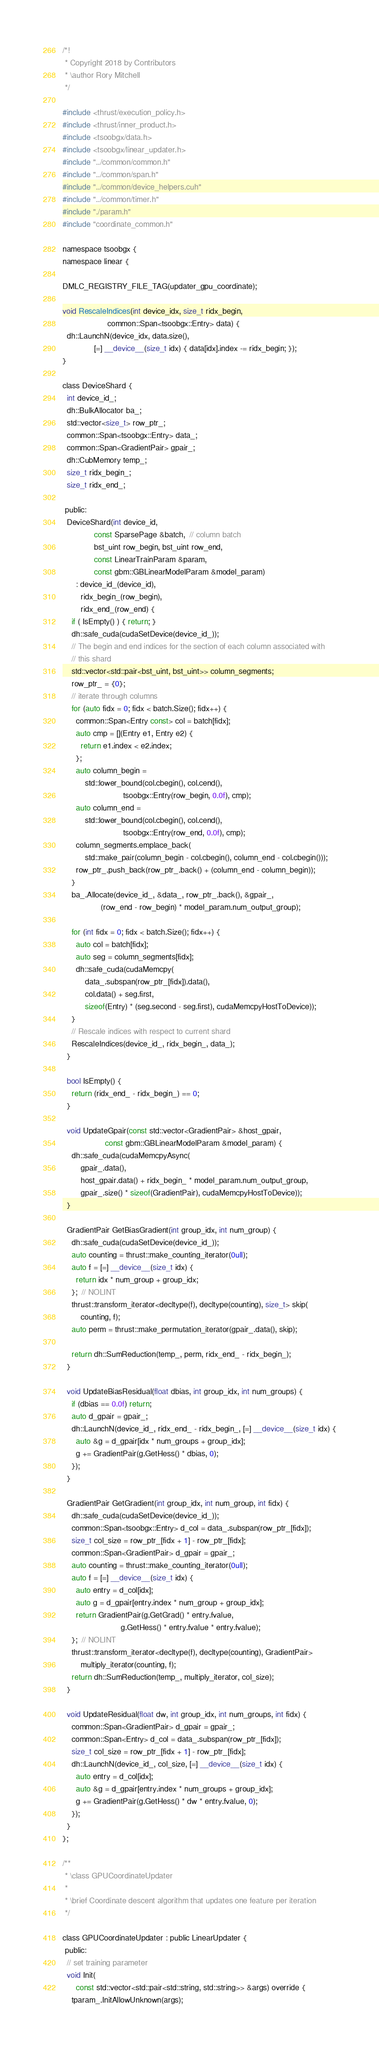<code> <loc_0><loc_0><loc_500><loc_500><_Cuda_>/*!
 * Copyright 2018 by Contributors
 * \author Rory Mitchell
 */

#include <thrust/execution_policy.h>
#include <thrust/inner_product.h>
#include <tsoobgx/data.h>
#include <tsoobgx/linear_updater.h>
#include "../common/common.h"
#include "../common/span.h"
#include "../common/device_helpers.cuh"
#include "../common/timer.h"
#include "./param.h"
#include "coordinate_common.h"

namespace tsoobgx {
namespace linear {

DMLC_REGISTRY_FILE_TAG(updater_gpu_coordinate);

void RescaleIndices(int device_idx, size_t ridx_begin,
                    common::Span<tsoobgx::Entry> data) {
  dh::LaunchN(device_idx, data.size(),
              [=] __device__(size_t idx) { data[idx].index -= ridx_begin; });
}

class DeviceShard {
  int device_id_;
  dh::BulkAllocator ba_;
  std::vector<size_t> row_ptr_;
  common::Span<tsoobgx::Entry> data_;
  common::Span<GradientPair> gpair_;
  dh::CubMemory temp_;
  size_t ridx_begin_;
  size_t ridx_end_;

 public:
  DeviceShard(int device_id,
              const SparsePage &batch,  // column batch
              bst_uint row_begin, bst_uint row_end,
              const LinearTrainParam &param,
              const gbm::GBLinearModelParam &model_param)
      : device_id_(device_id),
        ridx_begin_(row_begin),
        ridx_end_(row_end) {
    if ( IsEmpty() ) { return; }
    dh::safe_cuda(cudaSetDevice(device_id_));
    // The begin and end indices for the section of each column associated with
    // this shard
    std::vector<std::pair<bst_uint, bst_uint>> column_segments;
    row_ptr_ = {0};
    // iterate through columns
    for (auto fidx = 0; fidx < batch.Size(); fidx++) {
      common::Span<Entry const> col = batch[fidx];
      auto cmp = [](Entry e1, Entry e2) {
        return e1.index < e2.index;
      };
      auto column_begin =
          std::lower_bound(col.cbegin(), col.cend(),
                           tsoobgx::Entry(row_begin, 0.0f), cmp);
      auto column_end =
          std::lower_bound(col.cbegin(), col.cend(),
                           tsoobgx::Entry(row_end, 0.0f), cmp);
      column_segments.emplace_back(
          std::make_pair(column_begin - col.cbegin(), column_end - col.cbegin()));
      row_ptr_.push_back(row_ptr_.back() + (column_end - column_begin));
    }
    ba_.Allocate(device_id_, &data_, row_ptr_.back(), &gpair_,
                 (row_end - row_begin) * model_param.num_output_group);

    for (int fidx = 0; fidx < batch.Size(); fidx++) {
      auto col = batch[fidx];
      auto seg = column_segments[fidx];
      dh::safe_cuda(cudaMemcpy(
          data_.subspan(row_ptr_[fidx]).data(),
          col.data() + seg.first,
          sizeof(Entry) * (seg.second - seg.first), cudaMemcpyHostToDevice));
    }
    // Rescale indices with respect to current shard
    RescaleIndices(device_id_, ridx_begin_, data_);
  }

  bool IsEmpty() {
    return (ridx_end_ - ridx_begin_) == 0;
  }

  void UpdateGpair(const std::vector<GradientPair> &host_gpair,
                   const gbm::GBLinearModelParam &model_param) {
    dh::safe_cuda(cudaMemcpyAsync(
        gpair_.data(),
        host_gpair.data() + ridx_begin_ * model_param.num_output_group,
        gpair_.size() * sizeof(GradientPair), cudaMemcpyHostToDevice));
  }

  GradientPair GetBiasGradient(int group_idx, int num_group) {
    dh::safe_cuda(cudaSetDevice(device_id_));
    auto counting = thrust::make_counting_iterator(0ull);
    auto f = [=] __device__(size_t idx) {
      return idx * num_group + group_idx;
    };  // NOLINT
    thrust::transform_iterator<decltype(f), decltype(counting), size_t> skip(
        counting, f);
    auto perm = thrust::make_permutation_iterator(gpair_.data(), skip);

    return dh::SumReduction(temp_, perm, ridx_end_ - ridx_begin_);
  }

  void UpdateBiasResidual(float dbias, int group_idx, int num_groups) {
    if (dbias == 0.0f) return;
    auto d_gpair = gpair_;
    dh::LaunchN(device_id_, ridx_end_ - ridx_begin_, [=] __device__(size_t idx) {
      auto &g = d_gpair[idx * num_groups + group_idx];
      g += GradientPair(g.GetHess() * dbias, 0);
    });
  }

  GradientPair GetGradient(int group_idx, int num_group, int fidx) {
    dh::safe_cuda(cudaSetDevice(device_id_));
    common::Span<tsoobgx::Entry> d_col = data_.subspan(row_ptr_[fidx]);
    size_t col_size = row_ptr_[fidx + 1] - row_ptr_[fidx];
    common::Span<GradientPair> d_gpair = gpair_;
    auto counting = thrust::make_counting_iterator(0ull);
    auto f = [=] __device__(size_t idx) {
      auto entry = d_col[idx];
      auto g = d_gpair[entry.index * num_group + group_idx];
      return GradientPair(g.GetGrad() * entry.fvalue,
                          g.GetHess() * entry.fvalue * entry.fvalue);
    };  // NOLINT
    thrust::transform_iterator<decltype(f), decltype(counting), GradientPair>
        multiply_iterator(counting, f);
    return dh::SumReduction(temp_, multiply_iterator, col_size);
  }

  void UpdateResidual(float dw, int group_idx, int num_groups, int fidx) {
    common::Span<GradientPair> d_gpair = gpair_;
    common::Span<Entry> d_col = data_.subspan(row_ptr_[fidx]);
    size_t col_size = row_ptr_[fidx + 1] - row_ptr_[fidx];
    dh::LaunchN(device_id_, col_size, [=] __device__(size_t idx) {
      auto entry = d_col[idx];
      auto &g = d_gpair[entry.index * num_groups + group_idx];
      g += GradientPair(g.GetHess() * dw * entry.fvalue, 0);
    });
  }
};

/**
 * \class GPUCoordinateUpdater
 *
 * \brief Coordinate descent algorithm that updates one feature per iteration
 */

class GPUCoordinateUpdater : public LinearUpdater {
 public:
  // set training parameter
  void Init(
      const std::vector<std::pair<std::string, std::string>> &args) override {
    tparam_.InitAllowUnknown(args);</code> 